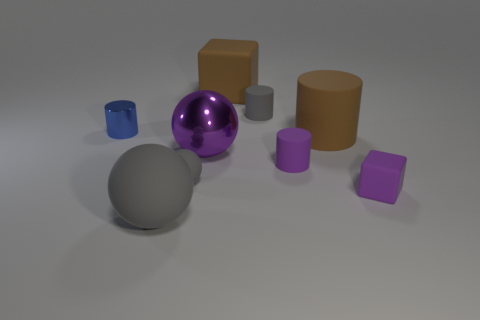Add 1 small gray metallic cylinders. How many objects exist? 10 Subtract all balls. How many objects are left? 6 Subtract 0 red cylinders. How many objects are left? 9 Subtract all blue cylinders. Subtract all tiny spheres. How many objects are left? 7 Add 7 small blue cylinders. How many small blue cylinders are left? 8 Add 1 purple things. How many purple things exist? 4 